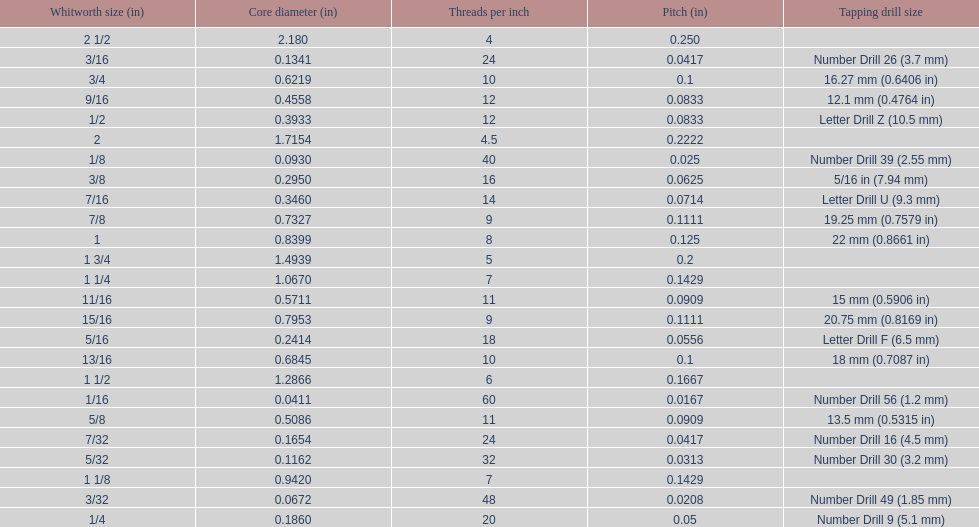What is the top amount of threads per inch? 60. 